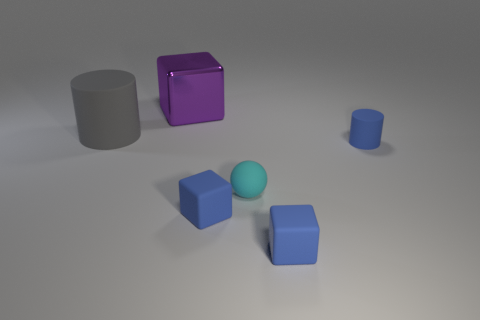Is there anything else that has the same material as the large purple block?
Your response must be concise. No. Do the gray rubber thing and the small rubber object that is behind the tiny cyan ball have the same shape?
Keep it short and to the point. Yes. The other object that is the same shape as the large gray thing is what size?
Offer a very short reply. Small. What number of other objects are there of the same material as the large cube?
Your answer should be very brief. 0. What is the big purple thing made of?
Ensure brevity in your answer.  Metal. Does the tiny rubber object that is left of the tiny sphere have the same color as the cube behind the big rubber thing?
Give a very brief answer. No. Is the number of blue matte cubes behind the large gray object greater than the number of big blue matte spheres?
Your response must be concise. No. How many other objects are the same color as the metal thing?
Your answer should be compact. 0. There is a cylinder that is to the right of the purple metallic cube; does it have the same size as the big metal block?
Give a very brief answer. No. Are there any cyan shiny blocks that have the same size as the purple block?
Offer a terse response. No. 